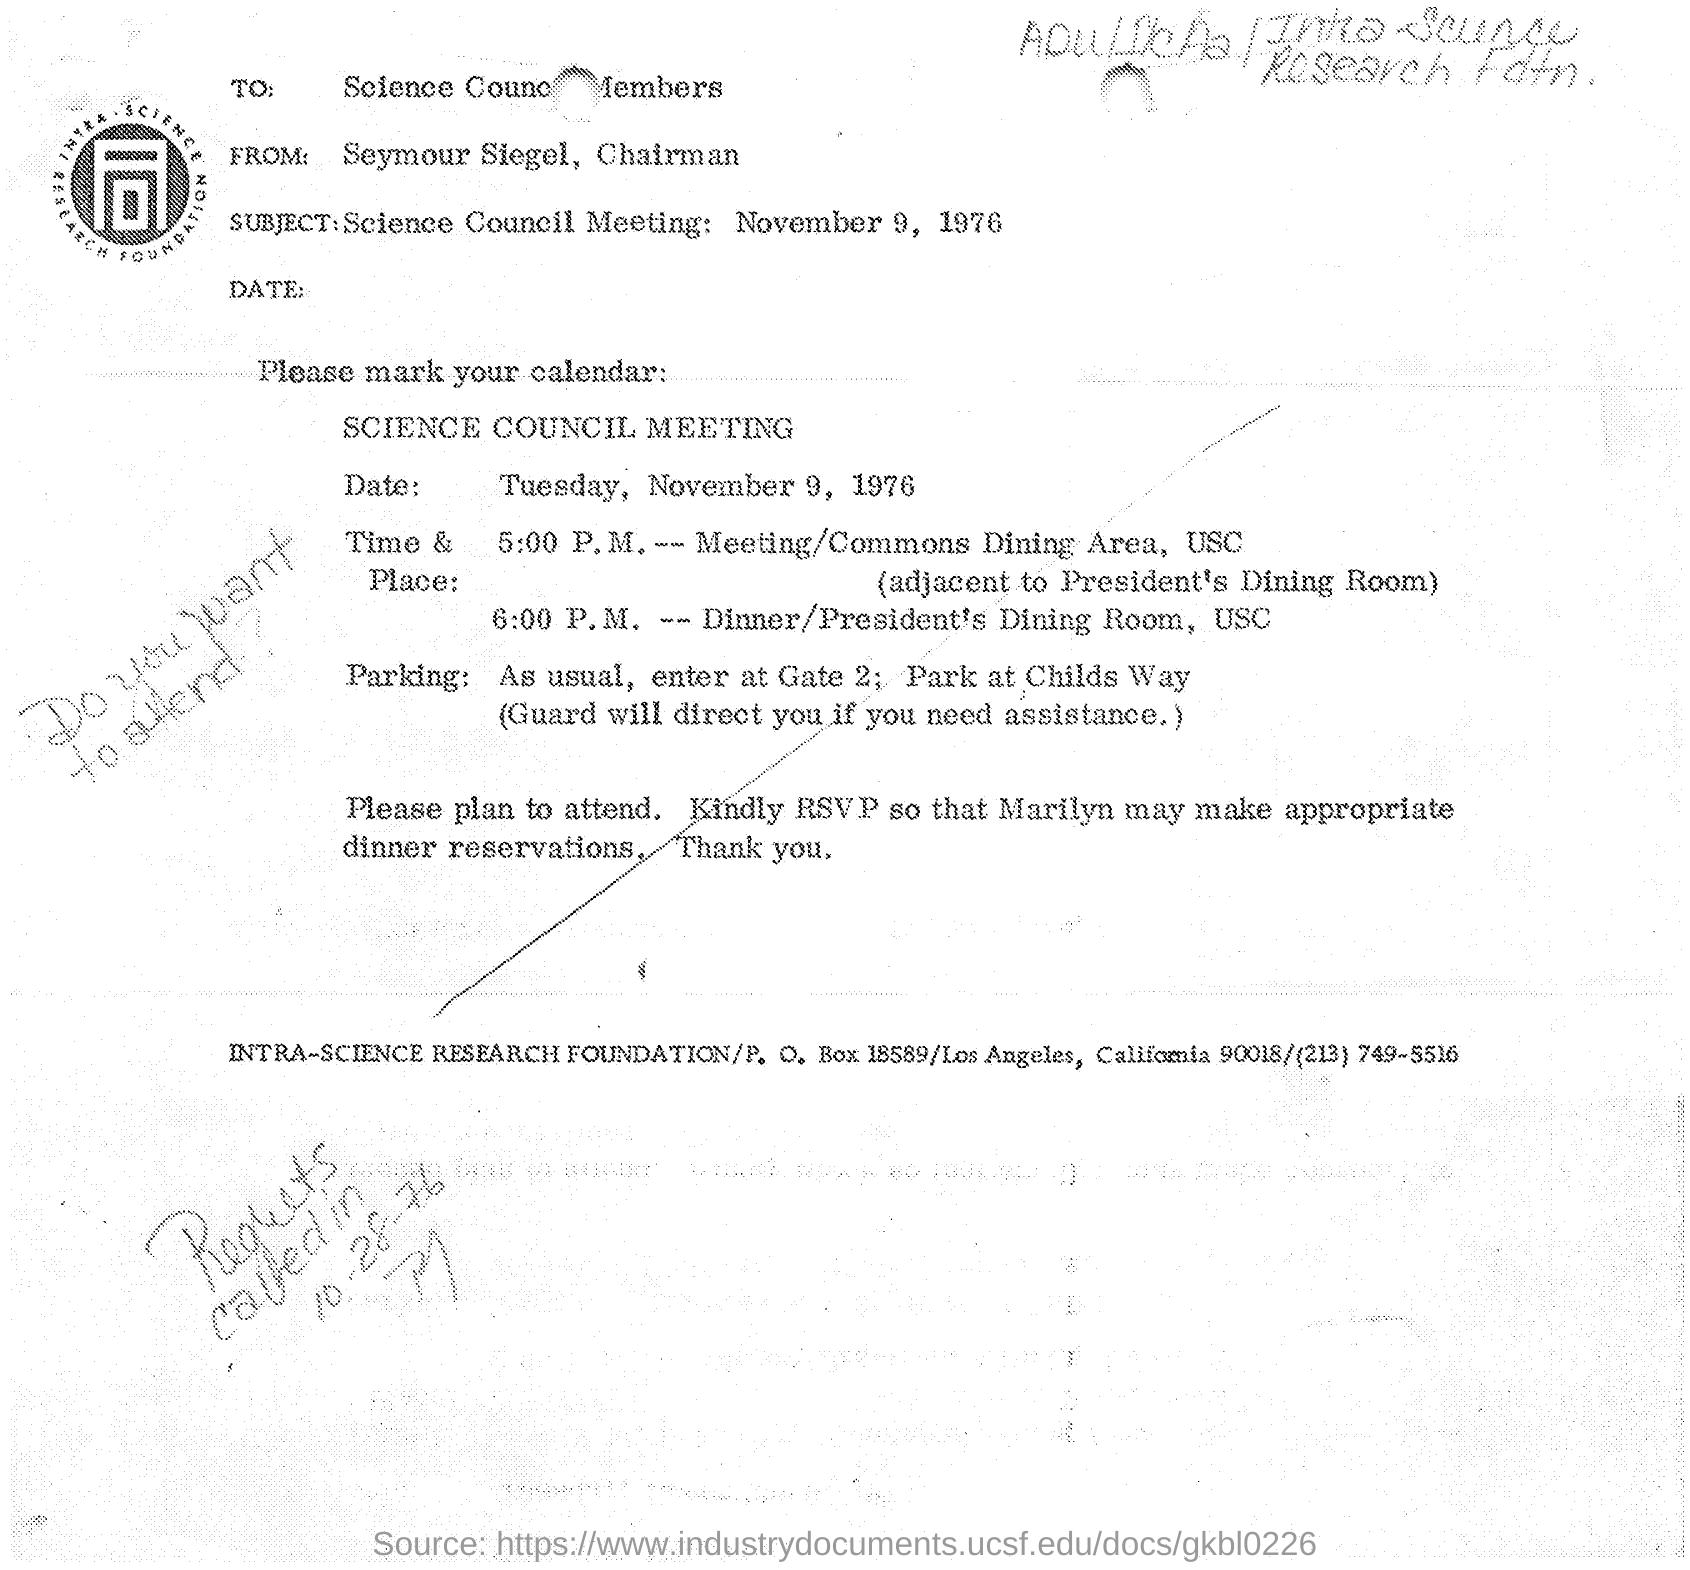What is the subject mentioned in the document?
Give a very brief answer. Science Council Meeting: November 9, 1976. Who is the sender of this document?
Ensure brevity in your answer.  Seymour Siegel, Chairman. Who is the receiver of this document?
Give a very brief answer. Science Council Members. When is the Science Council Meeting held?
Keep it short and to the point. November 9, 1976. Which Company's Meeting Schedule is this?
Keep it short and to the point. INTRA-SCIENCE RESEARCH FOUNDATION. 